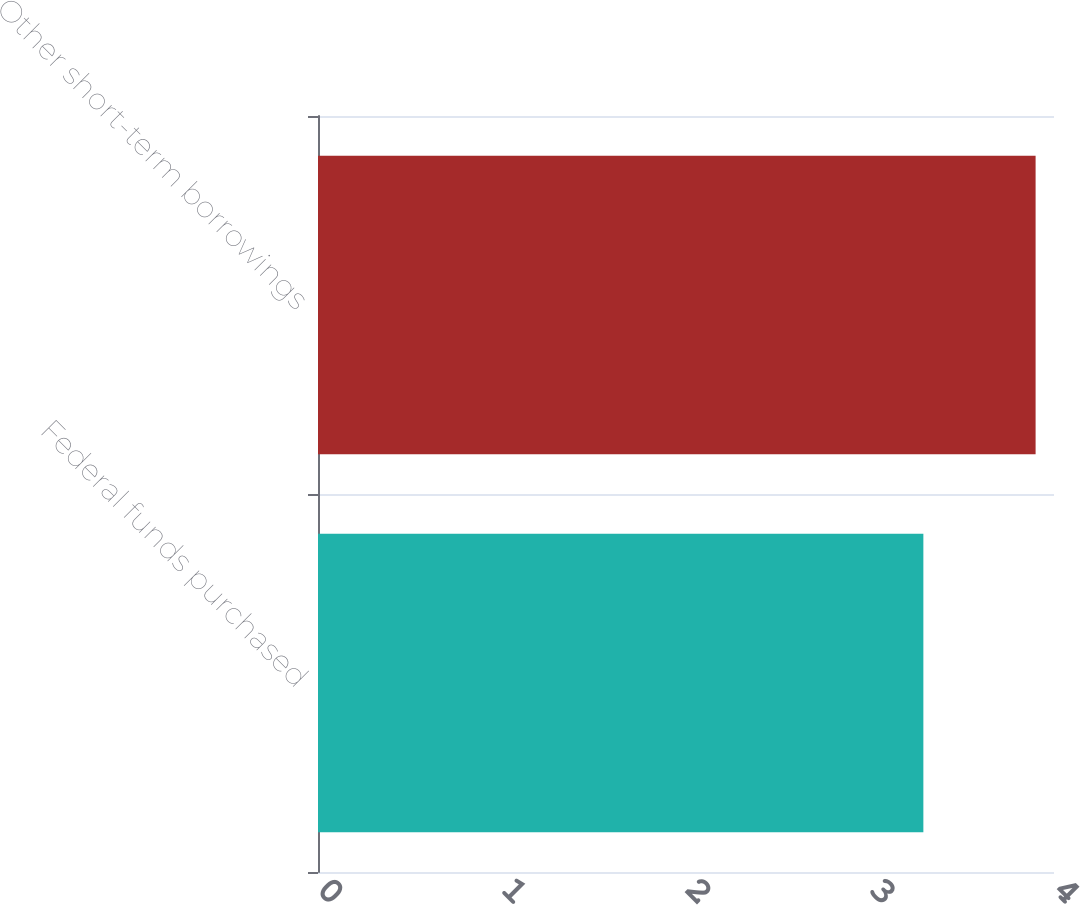Convert chart to OTSL. <chart><loc_0><loc_0><loc_500><loc_500><bar_chart><fcel>Federal funds purchased<fcel>Other short-term borrowings<nl><fcel>3.29<fcel>3.9<nl></chart> 